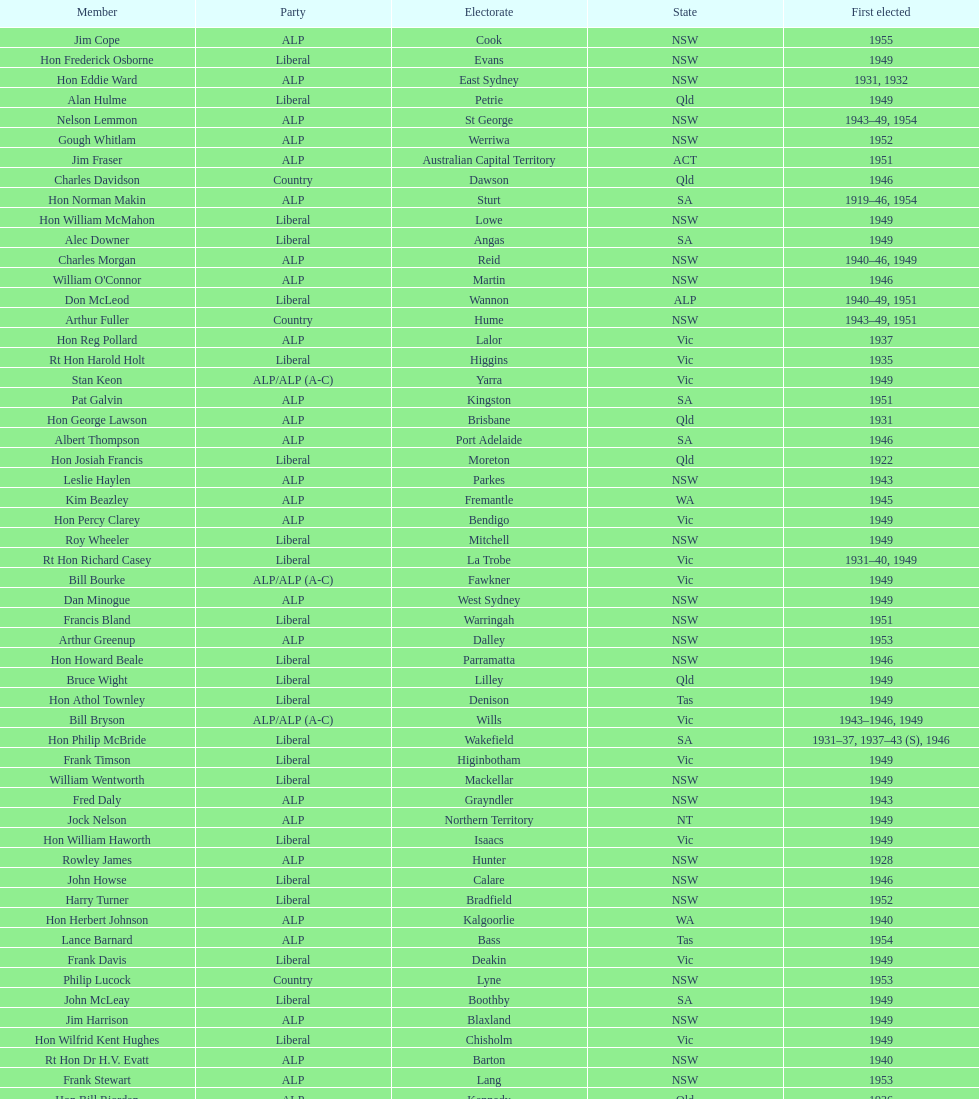Previous to tom andrews who was elected? Gordon Anderson. 